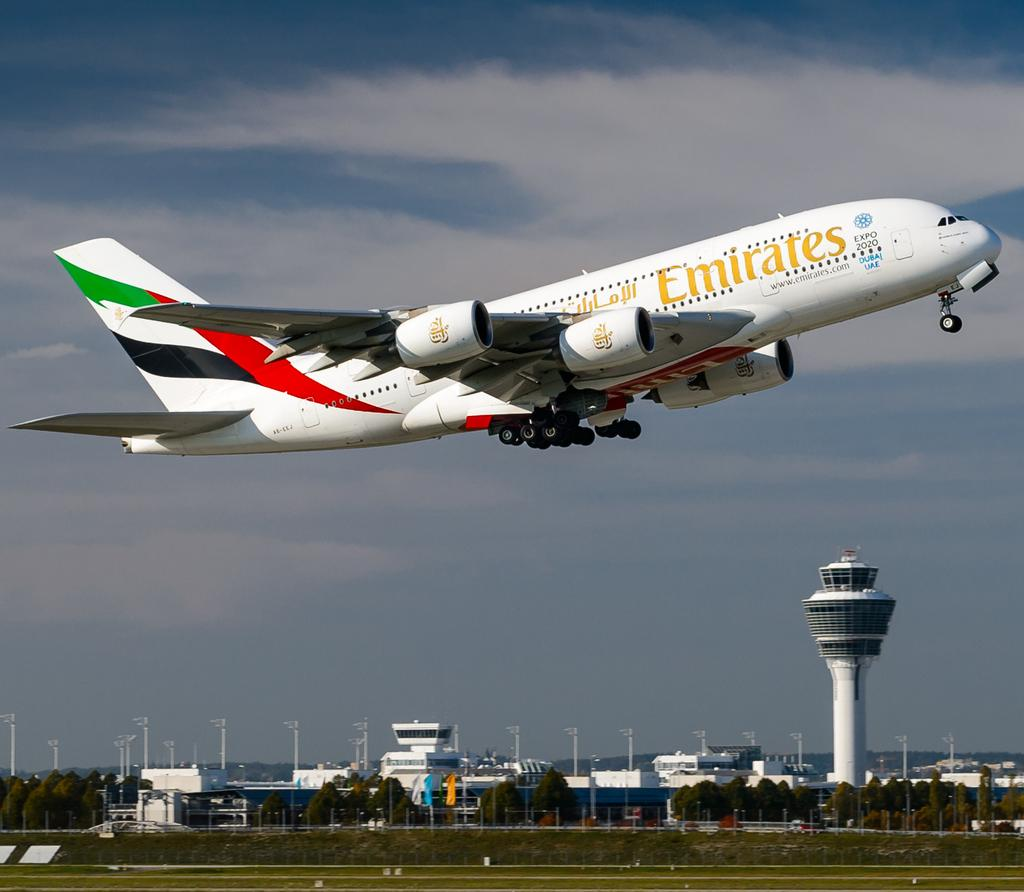<image>
Summarize the visual content of the image. Fly Emirates Airplane taking off from the airport. 